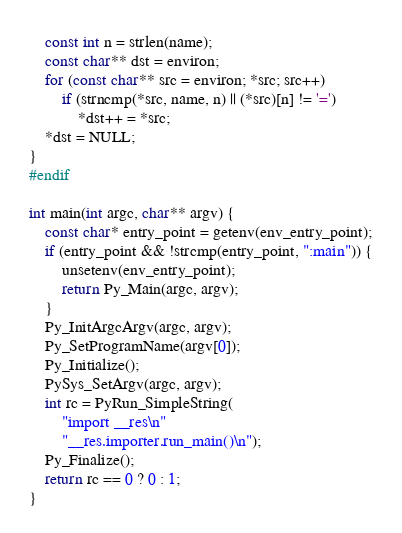Convert code to text. <code><loc_0><loc_0><loc_500><loc_500><_C_>    const int n = strlen(name);
    const char** dst = environ;
    for (const char** src = environ; *src; src++)
        if (strncmp(*src, name, n) || (*src)[n] != '=')
            *dst++ = *src;
    *dst = NULL;
}
#endif

int main(int argc, char** argv) {
    const char* entry_point = getenv(env_entry_point);
    if (entry_point && !strcmp(entry_point, ":main")) {
        unsetenv(env_entry_point);
        return Py_Main(argc, argv);
    }
    Py_InitArgcArgv(argc, argv);
    Py_SetProgramName(argv[0]);
    Py_Initialize();
    PySys_SetArgv(argc, argv);
    int rc = PyRun_SimpleString(
        "import __res\n"
        "__res.importer.run_main()\n");
    Py_Finalize();
    return rc == 0 ? 0 : 1;
}
</code> 